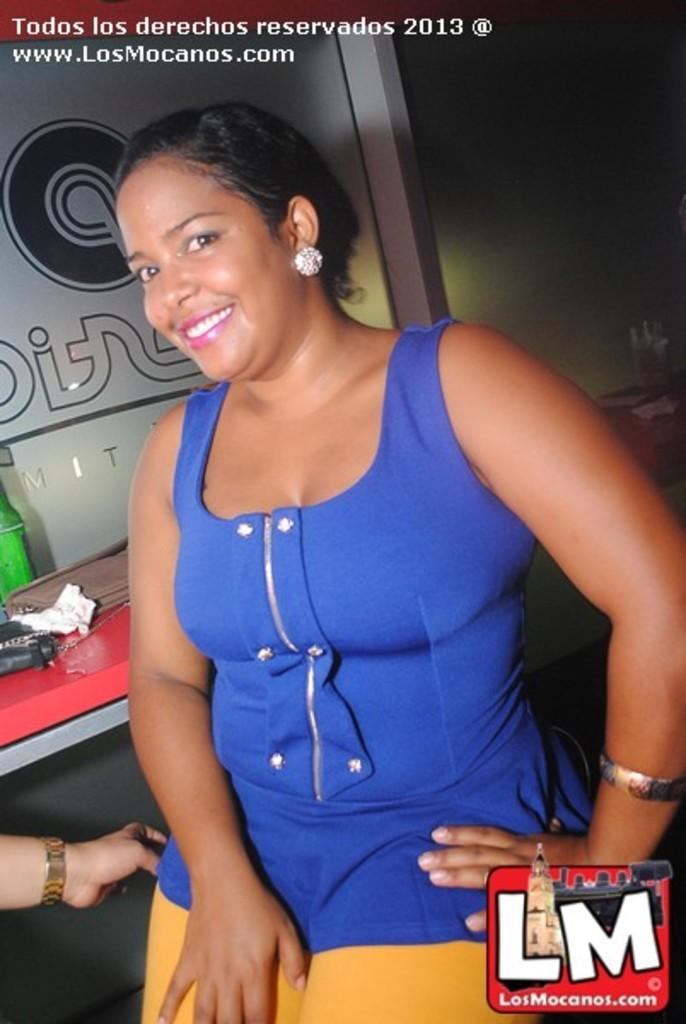Provide a one-sentence caption for the provided image. An advertisement with a woman in a blue top for the website losmocanos.com. 